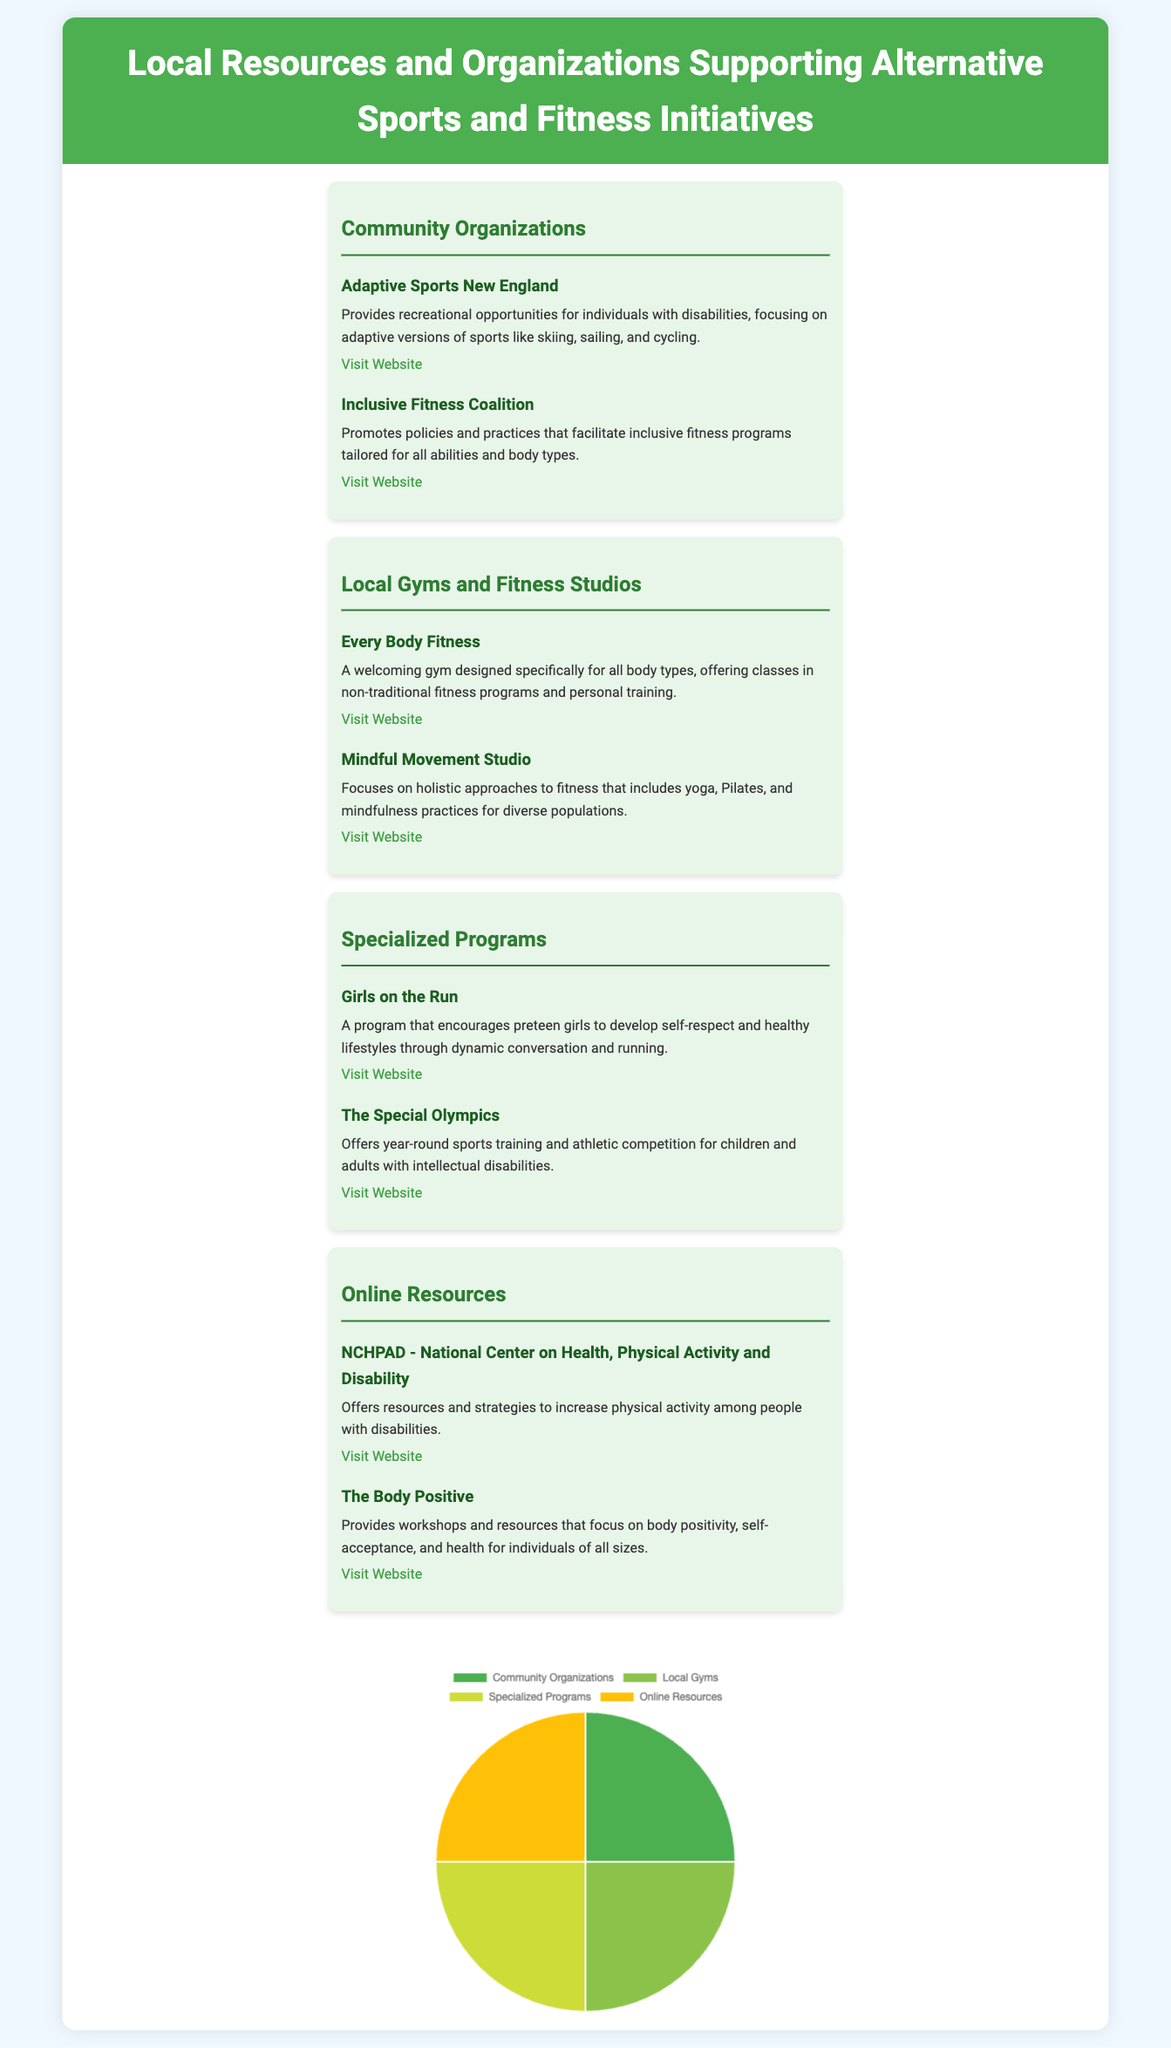What are the names of two community organizations? The document lists Adaptive Sports New England and Inclusive Fitness Coalition as community organizations.
Answer: Adaptive Sports New England, Inclusive Fitness Coalition What type of programs does Every Body Fitness offer? Every Body Fitness specializes in non-traditional fitness programs tailored for all body types.
Answer: Non-traditional fitness programs What is the focus of the Girls on the Run program? Girls on the Run aims to develop self-respect and healthy lifestyles among preteen girls through conversation and running.
Answer: Self-respect and healthy lifestyles Which online resource offers strategies for increasing physical activity among people with disabilities? The National Center on Health, Physical Activity and Disability (NCHPAD) provides resources for this purpose.
Answer: NCHPAD How many sections are there in the infographic? The infographic contains four distinct sections: Community Organizations, Local Gyms and Fitness Studios, Specialized Programs, and Online Resources.
Answer: Four What chart type is used to represent the distribution of resources? The document uses a pie chart to display the distribution of resources.
Answer: Pie chart What is the primary color theme of the header section? The header section has a background color of green (#4CAF50) with white text.
Answer: Green What does the inclusion of a chart suggest about the information? The inclusion of a chart indicates that the document presents quantitative data related to the resources.
Answer: Quantitative data 